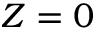<formula> <loc_0><loc_0><loc_500><loc_500>Z = 0</formula> 